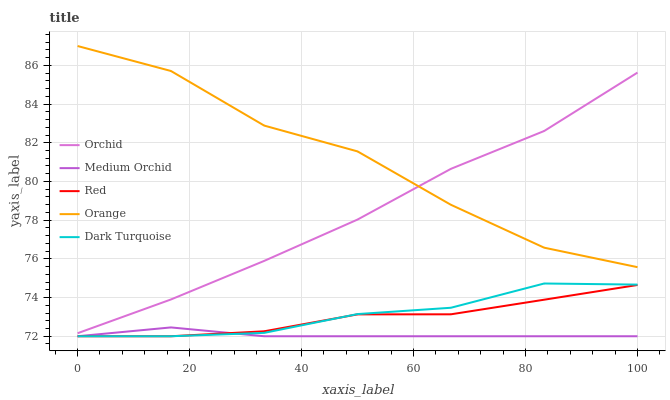Does Medium Orchid have the minimum area under the curve?
Answer yes or no. Yes. Does Orange have the maximum area under the curve?
Answer yes or no. Yes. Does Dark Turquoise have the minimum area under the curve?
Answer yes or no. No. Does Dark Turquoise have the maximum area under the curve?
Answer yes or no. No. Is Medium Orchid the smoothest?
Answer yes or no. Yes. Is Orange the roughest?
Answer yes or no. Yes. Is Dark Turquoise the smoothest?
Answer yes or no. No. Is Dark Turquoise the roughest?
Answer yes or no. No. Does Dark Turquoise have the lowest value?
Answer yes or no. Yes. Does Orchid have the lowest value?
Answer yes or no. No. Does Orange have the highest value?
Answer yes or no. Yes. Does Dark Turquoise have the highest value?
Answer yes or no. No. Is Dark Turquoise less than Orchid?
Answer yes or no. Yes. Is Orchid greater than Dark Turquoise?
Answer yes or no. Yes. Does Dark Turquoise intersect Red?
Answer yes or no. Yes. Is Dark Turquoise less than Red?
Answer yes or no. No. Is Dark Turquoise greater than Red?
Answer yes or no. No. Does Dark Turquoise intersect Orchid?
Answer yes or no. No. 